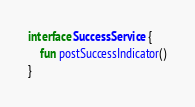Convert code to text. <code><loc_0><loc_0><loc_500><loc_500><_Kotlin_>
interface SuccessService {
    fun postSuccessIndicator()
}
</code> 